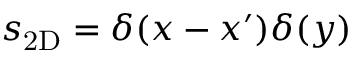<formula> <loc_0><loc_0><loc_500><loc_500>s _ { 2 D } = \delta ( x - x ^ { \prime } ) \delta ( y )</formula> 